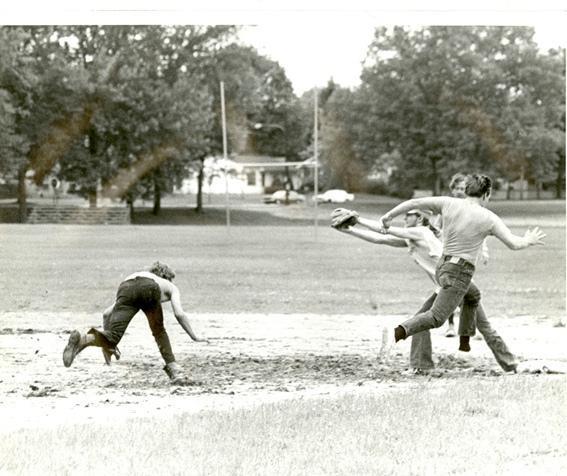How many people are there?
Give a very brief answer. 3. 